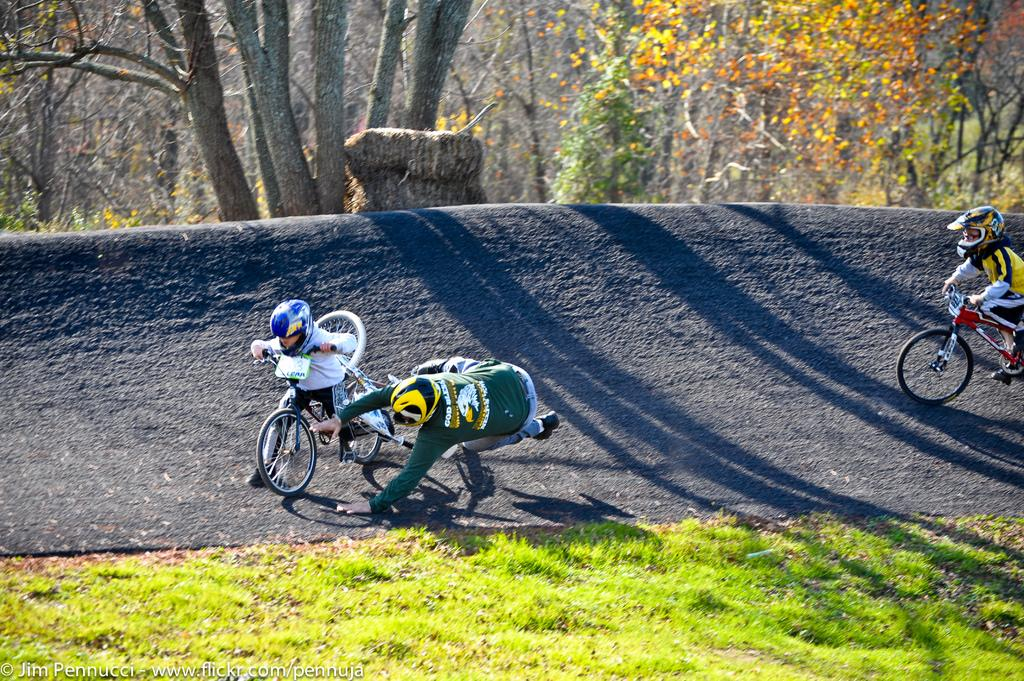What type of vegetation is present at the bottom of the image? There is grass on the ground at the bottom of the image. What is the terrain like behind the grass? There is a slope behind the grass. What are the people in the image doing on the slope? There are people riding bicycles on the slope. What can be seen at the top of the image? There are many trees at the top of the image. Where is the cow positioned in the image? There is no cow present in the image. What type of lettuce can be seen growing on the slope? There is no lettuce visible in the image; it features grass, a slope, trees, and people riding bicycles. 